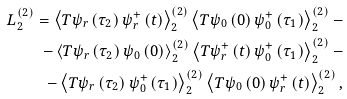Convert formula to latex. <formula><loc_0><loc_0><loc_500><loc_500>L _ { 2 } ^ { ( 2 ) } = \left \langle T \psi _ { r } \left ( \tau _ { 2 } \right ) \psi _ { r } ^ { + } \left ( t \right ) \right \rangle _ { 2 } ^ { ( 2 ) } \left \langle T \psi _ { 0 } \left ( 0 \right ) \psi _ { 0 } ^ { + } \left ( \tau _ { 1 } \right ) \right \rangle _ { 2 } ^ { ( 2 ) } - \\ - \left \langle T \psi _ { r } \left ( \tau _ { 2 } \right ) \psi _ { 0 } \left ( 0 \right ) \right \rangle _ { 2 } ^ { ( 2 ) } \left \langle T \psi _ { r } ^ { + } \left ( t \right ) \psi _ { 0 } ^ { + } \left ( \tau _ { 1 } \right ) \right \rangle _ { 2 } ^ { ( 2 ) } - \\ - \left \langle T \psi _ { r } \left ( \tau _ { 2 } \right ) \psi _ { 0 } ^ { + } \left ( \tau _ { 1 } \right ) \right \rangle _ { 2 } ^ { ( 2 ) } \left \langle T \psi _ { 0 } \left ( 0 \right ) \psi _ { r } ^ { + } \left ( t \right ) \right \rangle _ { 2 } ^ { ( 2 ) } ,</formula> 